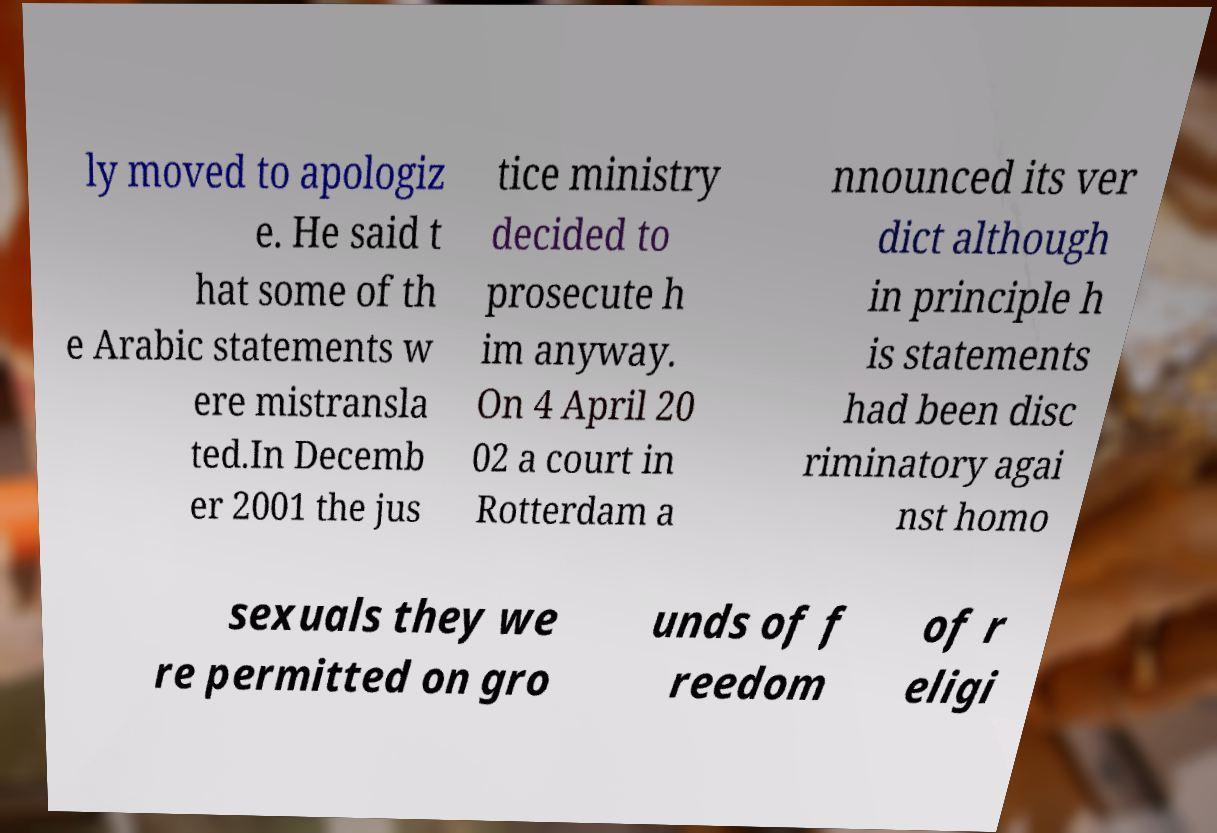I need the written content from this picture converted into text. Can you do that? ly moved to apologiz e. He said t hat some of th e Arabic statements w ere mistransla ted.In Decemb er 2001 the jus tice ministry decided to prosecute h im anyway. On 4 April 20 02 a court in Rotterdam a nnounced its ver dict although in principle h is statements had been disc riminatory agai nst homo sexuals they we re permitted on gro unds of f reedom of r eligi 